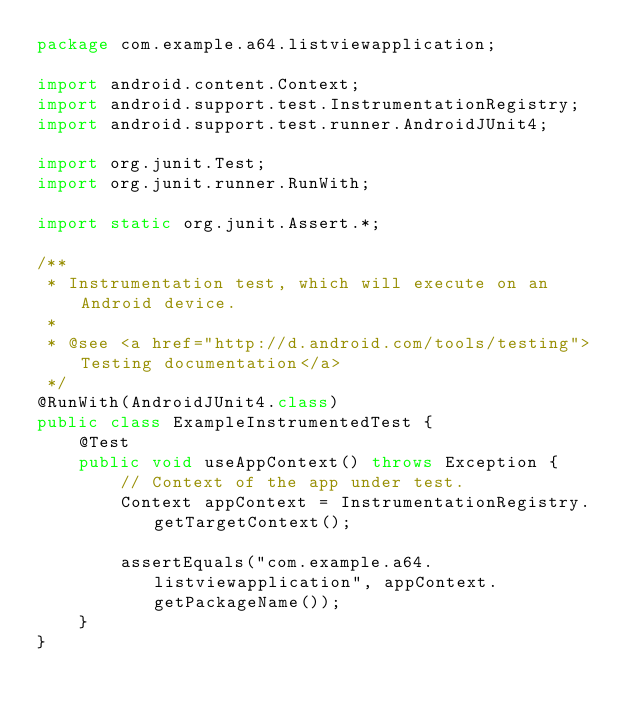Convert code to text. <code><loc_0><loc_0><loc_500><loc_500><_Java_>package com.example.a64.listviewapplication;

import android.content.Context;
import android.support.test.InstrumentationRegistry;
import android.support.test.runner.AndroidJUnit4;

import org.junit.Test;
import org.junit.runner.RunWith;

import static org.junit.Assert.*;

/**
 * Instrumentation test, which will execute on an Android device.
 *
 * @see <a href="http://d.android.com/tools/testing">Testing documentation</a>
 */
@RunWith(AndroidJUnit4.class)
public class ExampleInstrumentedTest {
    @Test
    public void useAppContext() throws Exception {
        // Context of the app under test.
        Context appContext = InstrumentationRegistry.getTargetContext();

        assertEquals("com.example.a64.listviewapplication", appContext.getPackageName());
    }
}
</code> 